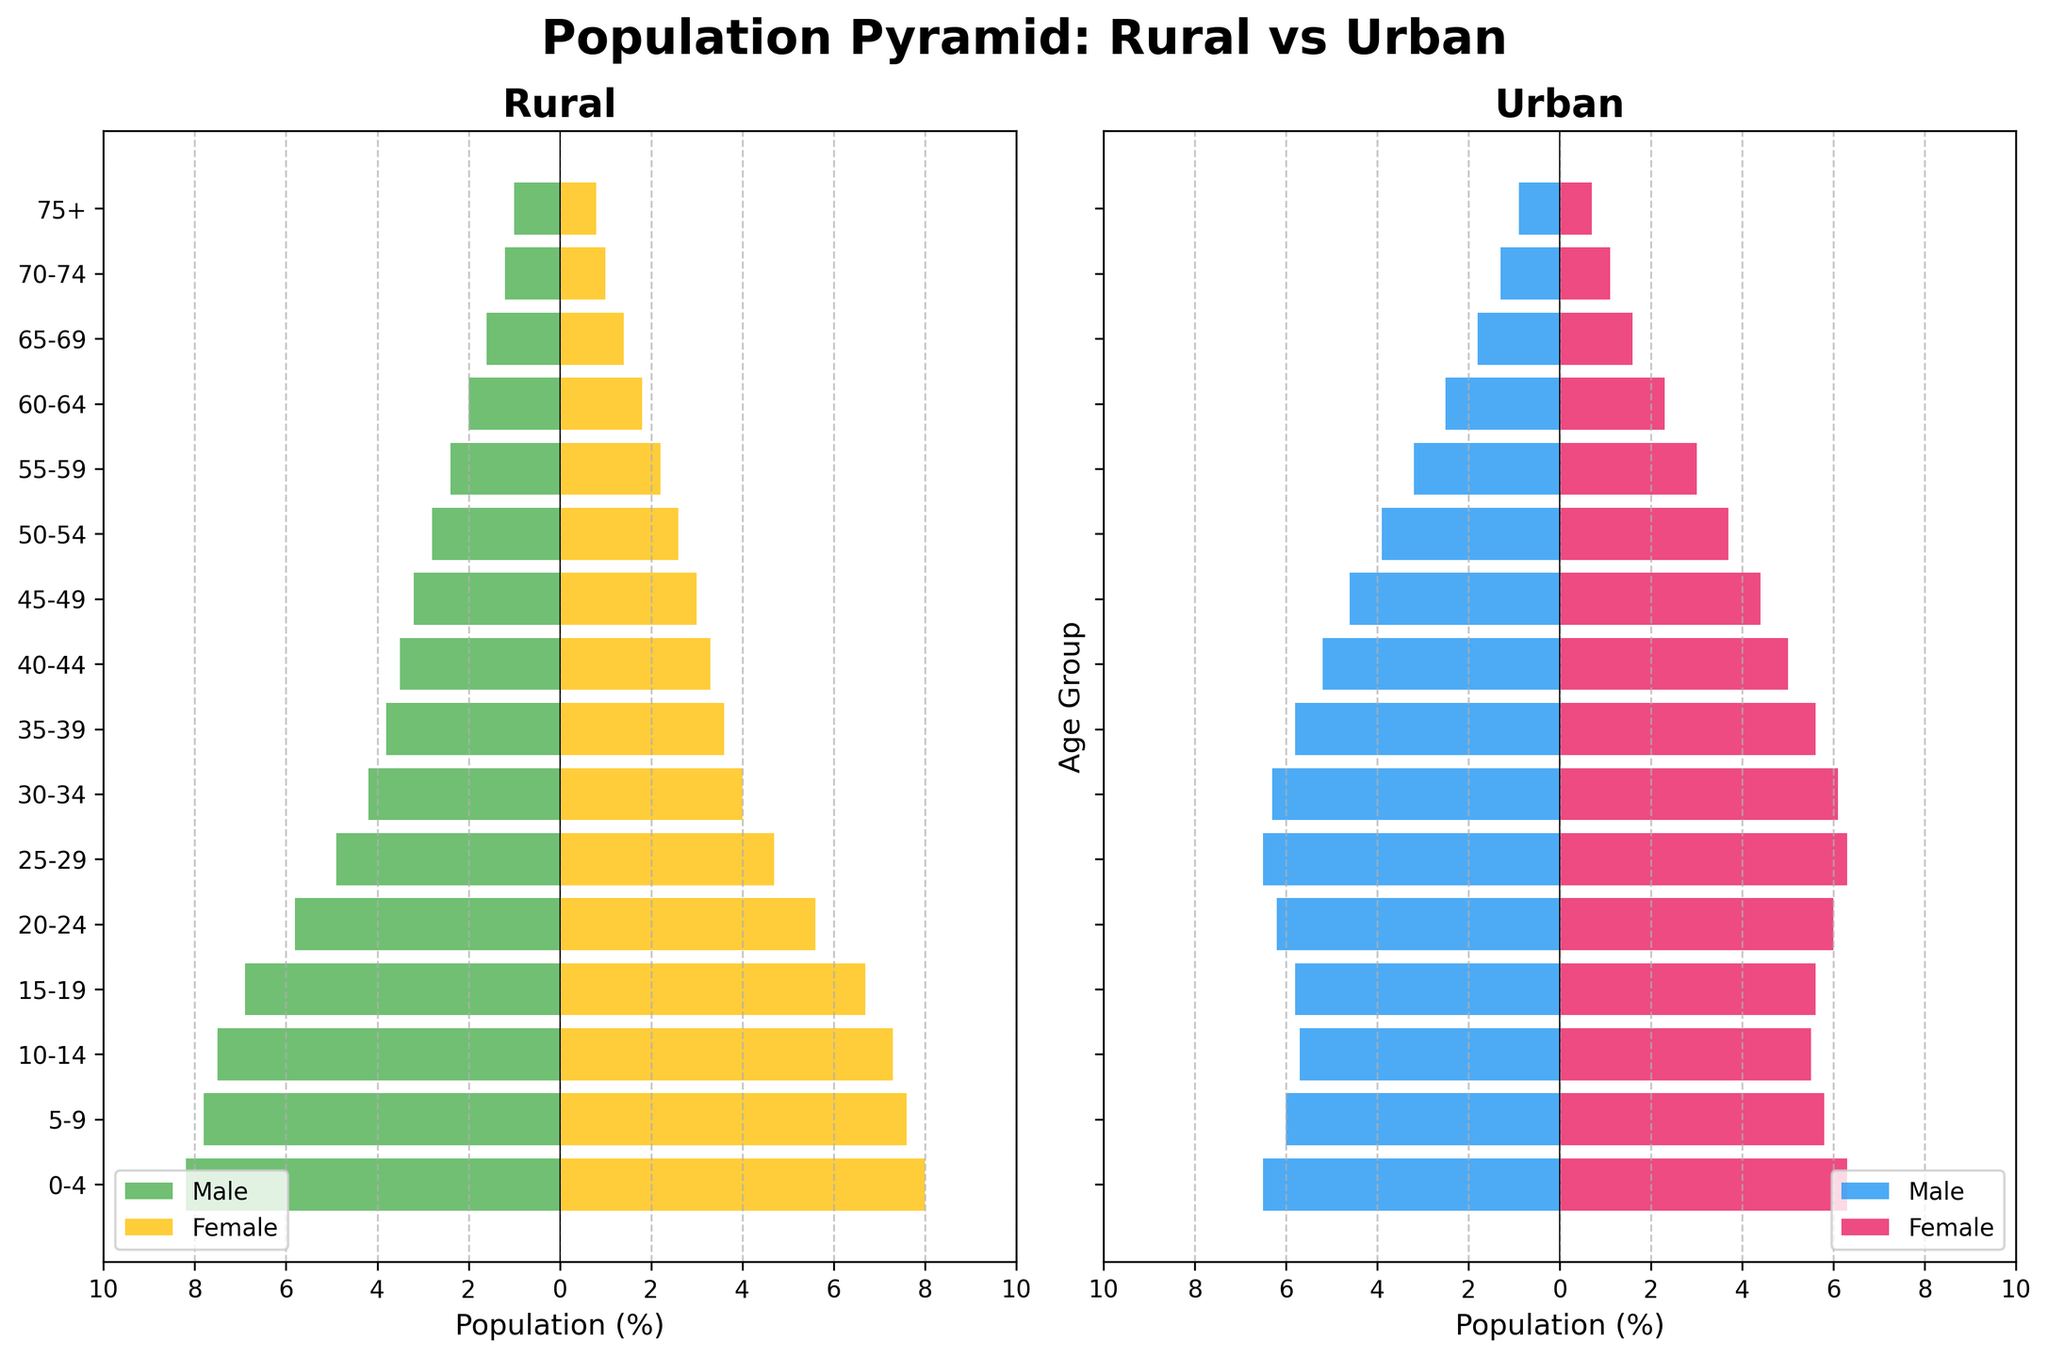Which age group has the largest rural male population percentage? The largest percentage for rural males is represented by the bar with the longest length to the left in the rural section. This corresponds to the age group 0-4.
Answer: 0-4 Which age group has the smallest urban female population percentage? The smallest percentage for urban females is represented by the bar with the shortest length to the right in the urban section. This corresponds to the age group 75+.
Answer: 75+ Compare the population percentages between rural and urban areas for the age group 25-29. Which area has a higher percentage for males and for females? For the age group 25-29, the urban male percentage (6.5%) is higher than the rural male percentage (4.9%). Similarly, the urban female percentage (6.3%) is higher than the rural female percentage (4.7%).
Answer: Urban has a higher percentage for both males and females How does the rural female population percentage in the age group 30-34 compare to the urban female population percentage in the same age group? The rural female percentage for the age group 30-34 is 4.0%, while the urban female percentage is 6.1%. Thus, the urban female percentage is higher.
Answer: Urban is higher What can you infer about migration patterns from rural to urban areas based on the population distribution of young adults? Observing the population distribution, young adults (especially those aged between 20-34) have higher percentages in urban areas compared to rural areas, suggesting a migration pattern wherein young adults move from rural to urban areas.
Answer: Young adults tend to migrate to urban areas Which age group shows a noticeable migration trend from rural areas to urban areas for males? For males aged 20-24, the urban percentage (6.2%) is higher compared to the rural percentage (5.8%), indicating noticeable migration from rural to urban areas in this age group.
Answer: 20-24 In which age group does the urban male population surpass the rural male population by the largest margin? To find the largest margin, calculate the difference between urban and rural male percentages for each age group. The age group 25-29 shows the largest margin with 6.5% (urban) compared to 4.9% (rural), producing a margin of 1.6%.
Answer: 25-29 What is the trend in female population percentages from rural to urban areas as age increases? By looking at the bars representing female populations, it is evident that younger age groups (0-19) have slightly higher percentages in rural areas, while older age groups (20+) have higher percentages in urban areas. This suggests that females might also migrate to urban areas as they age.
Answer: Older females tend to migrate to urban areas When comparing the age group 55-59, which gender has a higher population percentage in urban areas? Within the age group 55-59 in urban areas, the female percentage is 3.0%, while the male percentage is 3.2%. Therefore, males have a higher population percentage.
Answer: Males Based on the figure, what can be inferred about the aging population in urban vs rural areas? Analyzing the 60+ age groups, both males and females have slightly higher percentages in urban areas compared to rural areas, suggesting that the aging population might prefer or have the means to live in urban areas.
Answer: Aging population is higher in urban areas 